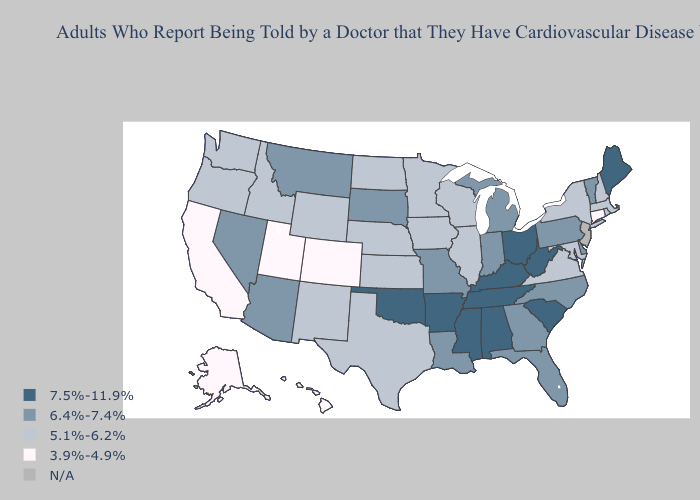Name the states that have a value in the range 6.4%-7.4%?
Give a very brief answer. Arizona, Delaware, Florida, Georgia, Indiana, Louisiana, Michigan, Missouri, Montana, Nevada, North Carolina, Pennsylvania, South Dakota, Vermont. Does Louisiana have the highest value in the USA?
Answer briefly. No. What is the value of Iowa?
Give a very brief answer. 5.1%-6.2%. Does the map have missing data?
Give a very brief answer. Yes. What is the value of Wisconsin?
Answer briefly. 5.1%-6.2%. Name the states that have a value in the range 5.1%-6.2%?
Concise answer only. Idaho, Illinois, Iowa, Kansas, Maryland, Massachusetts, Minnesota, Nebraska, New Hampshire, New Mexico, New York, North Dakota, Oregon, Rhode Island, Texas, Virginia, Washington, Wisconsin, Wyoming. Which states have the lowest value in the Northeast?
Answer briefly. Connecticut. What is the highest value in the West ?
Write a very short answer. 6.4%-7.4%. What is the value of Kansas?
Quick response, please. 5.1%-6.2%. What is the highest value in states that border Colorado?
Short answer required. 7.5%-11.9%. Among the states that border South Dakota , does Minnesota have the lowest value?
Quick response, please. Yes. What is the value of Colorado?
Be succinct. 3.9%-4.9%. Is the legend a continuous bar?
Keep it brief. No. Name the states that have a value in the range N/A?
Write a very short answer. New Jersey. 